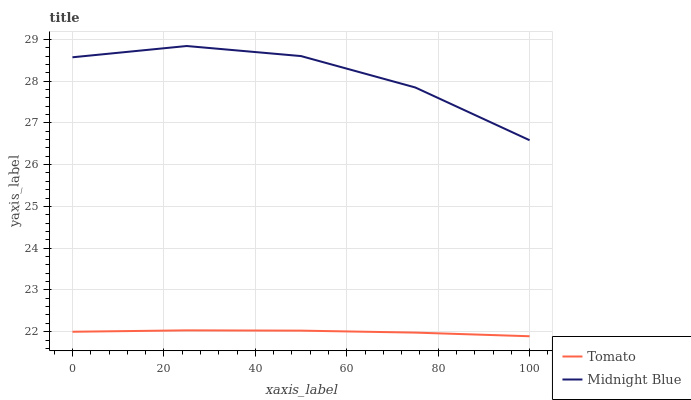Does Tomato have the minimum area under the curve?
Answer yes or no. Yes. Does Midnight Blue have the maximum area under the curve?
Answer yes or no. Yes. Does Midnight Blue have the minimum area under the curve?
Answer yes or no. No. Is Tomato the smoothest?
Answer yes or no. Yes. Is Midnight Blue the roughest?
Answer yes or no. Yes. Is Midnight Blue the smoothest?
Answer yes or no. No. Does Midnight Blue have the lowest value?
Answer yes or no. No. Is Tomato less than Midnight Blue?
Answer yes or no. Yes. Is Midnight Blue greater than Tomato?
Answer yes or no. Yes. Does Tomato intersect Midnight Blue?
Answer yes or no. No. 